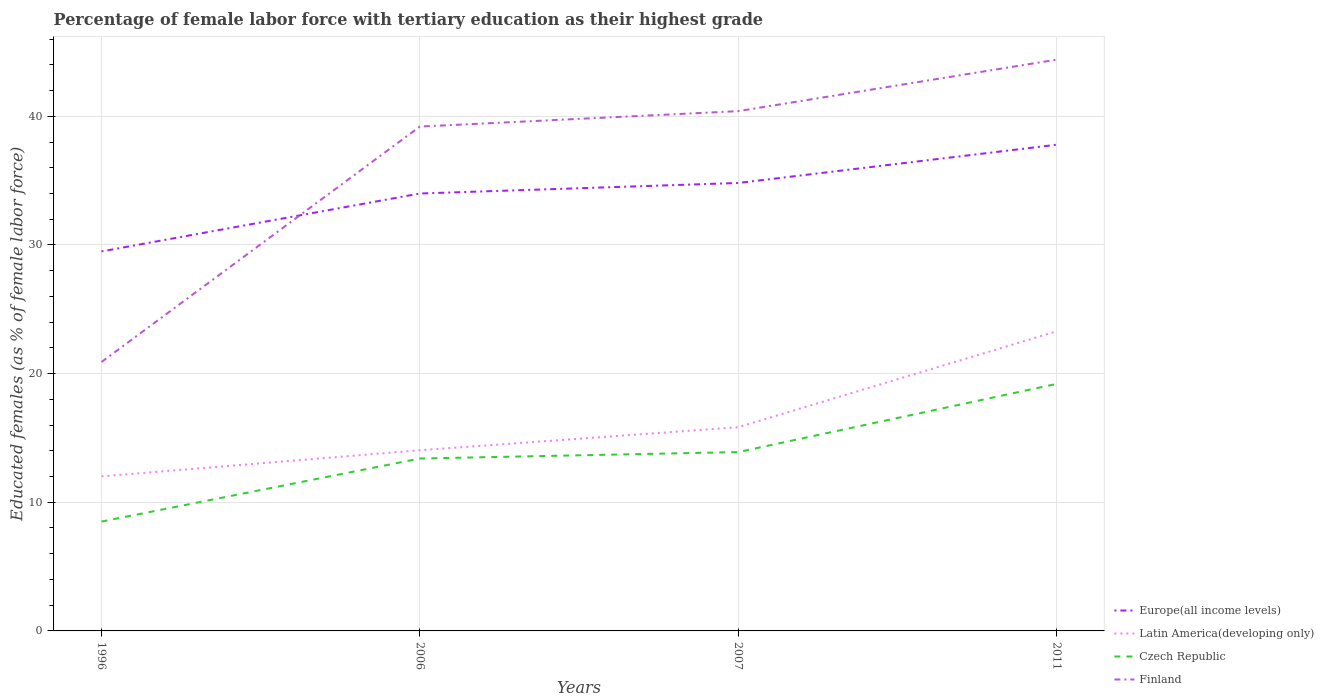How many different coloured lines are there?
Offer a terse response. 4. Is the number of lines equal to the number of legend labels?
Keep it short and to the point. Yes. Across all years, what is the maximum percentage of female labor force with tertiary education in Latin America(developing only)?
Your answer should be very brief. 12.01. In which year was the percentage of female labor force with tertiary education in Czech Republic maximum?
Make the answer very short. 1996. What is the total percentage of female labor force with tertiary education in Europe(all income levels) in the graph?
Your answer should be compact. -0.82. What is the difference between the highest and the second highest percentage of female labor force with tertiary education in Europe(all income levels)?
Make the answer very short. 8.29. What is the difference between the highest and the lowest percentage of female labor force with tertiary education in Finland?
Give a very brief answer. 3. How many lines are there?
Keep it short and to the point. 4. What is the difference between two consecutive major ticks on the Y-axis?
Provide a succinct answer. 10. Where does the legend appear in the graph?
Keep it short and to the point. Bottom right. What is the title of the graph?
Your response must be concise. Percentage of female labor force with tertiary education as their highest grade. Does "Haiti" appear as one of the legend labels in the graph?
Make the answer very short. No. What is the label or title of the X-axis?
Your answer should be very brief. Years. What is the label or title of the Y-axis?
Provide a short and direct response. Educated females (as % of female labor force). What is the Educated females (as % of female labor force) in Europe(all income levels) in 1996?
Your answer should be compact. 29.5. What is the Educated females (as % of female labor force) of Latin America(developing only) in 1996?
Your response must be concise. 12.01. What is the Educated females (as % of female labor force) in Czech Republic in 1996?
Make the answer very short. 8.5. What is the Educated females (as % of female labor force) in Finland in 1996?
Provide a short and direct response. 20.9. What is the Educated females (as % of female labor force) in Europe(all income levels) in 2006?
Your answer should be very brief. 34. What is the Educated females (as % of female labor force) of Latin America(developing only) in 2006?
Offer a terse response. 14.04. What is the Educated females (as % of female labor force) in Czech Republic in 2006?
Offer a very short reply. 13.4. What is the Educated females (as % of female labor force) in Finland in 2006?
Offer a terse response. 39.2. What is the Educated females (as % of female labor force) in Europe(all income levels) in 2007?
Ensure brevity in your answer.  34.82. What is the Educated females (as % of female labor force) in Latin America(developing only) in 2007?
Provide a short and direct response. 15.83. What is the Educated females (as % of female labor force) of Czech Republic in 2007?
Offer a very short reply. 13.9. What is the Educated females (as % of female labor force) in Finland in 2007?
Ensure brevity in your answer.  40.4. What is the Educated females (as % of female labor force) of Europe(all income levels) in 2011?
Your answer should be compact. 37.79. What is the Educated females (as % of female labor force) of Latin America(developing only) in 2011?
Make the answer very short. 23.28. What is the Educated females (as % of female labor force) of Czech Republic in 2011?
Your answer should be compact. 19.2. What is the Educated females (as % of female labor force) in Finland in 2011?
Offer a very short reply. 44.4. Across all years, what is the maximum Educated females (as % of female labor force) in Europe(all income levels)?
Your answer should be compact. 37.79. Across all years, what is the maximum Educated females (as % of female labor force) in Latin America(developing only)?
Offer a terse response. 23.28. Across all years, what is the maximum Educated females (as % of female labor force) of Czech Republic?
Your answer should be compact. 19.2. Across all years, what is the maximum Educated females (as % of female labor force) of Finland?
Offer a very short reply. 44.4. Across all years, what is the minimum Educated females (as % of female labor force) of Europe(all income levels)?
Make the answer very short. 29.5. Across all years, what is the minimum Educated females (as % of female labor force) of Latin America(developing only)?
Make the answer very short. 12.01. Across all years, what is the minimum Educated females (as % of female labor force) in Finland?
Give a very brief answer. 20.9. What is the total Educated females (as % of female labor force) of Europe(all income levels) in the graph?
Offer a terse response. 136.1. What is the total Educated females (as % of female labor force) of Latin America(developing only) in the graph?
Offer a very short reply. 65.17. What is the total Educated females (as % of female labor force) in Finland in the graph?
Your response must be concise. 144.9. What is the difference between the Educated females (as % of female labor force) of Europe(all income levels) in 1996 and that in 2006?
Your answer should be very brief. -4.5. What is the difference between the Educated females (as % of female labor force) of Latin America(developing only) in 1996 and that in 2006?
Provide a succinct answer. -2.03. What is the difference between the Educated females (as % of female labor force) of Finland in 1996 and that in 2006?
Give a very brief answer. -18.3. What is the difference between the Educated females (as % of female labor force) in Europe(all income levels) in 1996 and that in 2007?
Offer a very short reply. -5.32. What is the difference between the Educated females (as % of female labor force) of Latin America(developing only) in 1996 and that in 2007?
Your answer should be very brief. -3.82. What is the difference between the Educated females (as % of female labor force) of Finland in 1996 and that in 2007?
Offer a very short reply. -19.5. What is the difference between the Educated females (as % of female labor force) in Europe(all income levels) in 1996 and that in 2011?
Make the answer very short. -8.29. What is the difference between the Educated females (as % of female labor force) in Latin America(developing only) in 1996 and that in 2011?
Your answer should be compact. -11.27. What is the difference between the Educated females (as % of female labor force) of Czech Republic in 1996 and that in 2011?
Your answer should be compact. -10.7. What is the difference between the Educated females (as % of female labor force) of Finland in 1996 and that in 2011?
Give a very brief answer. -23.5. What is the difference between the Educated females (as % of female labor force) in Europe(all income levels) in 2006 and that in 2007?
Keep it short and to the point. -0.82. What is the difference between the Educated females (as % of female labor force) of Latin America(developing only) in 2006 and that in 2007?
Provide a succinct answer. -1.79. What is the difference between the Educated females (as % of female labor force) in Europe(all income levels) in 2006 and that in 2011?
Provide a succinct answer. -3.79. What is the difference between the Educated females (as % of female labor force) of Latin America(developing only) in 2006 and that in 2011?
Make the answer very short. -9.24. What is the difference between the Educated females (as % of female labor force) of Czech Republic in 2006 and that in 2011?
Offer a terse response. -5.8. What is the difference between the Educated females (as % of female labor force) in Europe(all income levels) in 2007 and that in 2011?
Provide a succinct answer. -2.97. What is the difference between the Educated females (as % of female labor force) in Latin America(developing only) in 2007 and that in 2011?
Make the answer very short. -7.45. What is the difference between the Educated females (as % of female labor force) of Finland in 2007 and that in 2011?
Give a very brief answer. -4. What is the difference between the Educated females (as % of female labor force) of Europe(all income levels) in 1996 and the Educated females (as % of female labor force) of Latin America(developing only) in 2006?
Offer a very short reply. 15.45. What is the difference between the Educated females (as % of female labor force) of Europe(all income levels) in 1996 and the Educated females (as % of female labor force) of Czech Republic in 2006?
Ensure brevity in your answer.  16.1. What is the difference between the Educated females (as % of female labor force) in Europe(all income levels) in 1996 and the Educated females (as % of female labor force) in Finland in 2006?
Offer a very short reply. -9.7. What is the difference between the Educated females (as % of female labor force) of Latin America(developing only) in 1996 and the Educated females (as % of female labor force) of Czech Republic in 2006?
Your answer should be very brief. -1.39. What is the difference between the Educated females (as % of female labor force) in Latin America(developing only) in 1996 and the Educated females (as % of female labor force) in Finland in 2006?
Offer a very short reply. -27.19. What is the difference between the Educated females (as % of female labor force) in Czech Republic in 1996 and the Educated females (as % of female labor force) in Finland in 2006?
Ensure brevity in your answer.  -30.7. What is the difference between the Educated females (as % of female labor force) of Europe(all income levels) in 1996 and the Educated females (as % of female labor force) of Latin America(developing only) in 2007?
Your response must be concise. 13.66. What is the difference between the Educated females (as % of female labor force) of Europe(all income levels) in 1996 and the Educated females (as % of female labor force) of Czech Republic in 2007?
Ensure brevity in your answer.  15.6. What is the difference between the Educated females (as % of female labor force) of Europe(all income levels) in 1996 and the Educated females (as % of female labor force) of Finland in 2007?
Provide a succinct answer. -10.9. What is the difference between the Educated females (as % of female labor force) in Latin America(developing only) in 1996 and the Educated females (as % of female labor force) in Czech Republic in 2007?
Your response must be concise. -1.89. What is the difference between the Educated females (as % of female labor force) of Latin America(developing only) in 1996 and the Educated females (as % of female labor force) of Finland in 2007?
Offer a very short reply. -28.39. What is the difference between the Educated females (as % of female labor force) of Czech Republic in 1996 and the Educated females (as % of female labor force) of Finland in 2007?
Your answer should be very brief. -31.9. What is the difference between the Educated females (as % of female labor force) of Europe(all income levels) in 1996 and the Educated females (as % of female labor force) of Latin America(developing only) in 2011?
Provide a short and direct response. 6.21. What is the difference between the Educated females (as % of female labor force) of Europe(all income levels) in 1996 and the Educated females (as % of female labor force) of Czech Republic in 2011?
Your answer should be very brief. 10.3. What is the difference between the Educated females (as % of female labor force) of Europe(all income levels) in 1996 and the Educated females (as % of female labor force) of Finland in 2011?
Your answer should be compact. -14.9. What is the difference between the Educated females (as % of female labor force) in Latin America(developing only) in 1996 and the Educated females (as % of female labor force) in Czech Republic in 2011?
Make the answer very short. -7.19. What is the difference between the Educated females (as % of female labor force) of Latin America(developing only) in 1996 and the Educated females (as % of female labor force) of Finland in 2011?
Your answer should be compact. -32.39. What is the difference between the Educated females (as % of female labor force) of Czech Republic in 1996 and the Educated females (as % of female labor force) of Finland in 2011?
Offer a very short reply. -35.9. What is the difference between the Educated females (as % of female labor force) in Europe(all income levels) in 2006 and the Educated females (as % of female labor force) in Latin America(developing only) in 2007?
Keep it short and to the point. 18.16. What is the difference between the Educated females (as % of female labor force) of Europe(all income levels) in 2006 and the Educated females (as % of female labor force) of Czech Republic in 2007?
Provide a short and direct response. 20.1. What is the difference between the Educated females (as % of female labor force) in Europe(all income levels) in 2006 and the Educated females (as % of female labor force) in Finland in 2007?
Provide a succinct answer. -6.4. What is the difference between the Educated females (as % of female labor force) of Latin America(developing only) in 2006 and the Educated females (as % of female labor force) of Czech Republic in 2007?
Give a very brief answer. 0.14. What is the difference between the Educated females (as % of female labor force) in Latin America(developing only) in 2006 and the Educated females (as % of female labor force) in Finland in 2007?
Keep it short and to the point. -26.36. What is the difference between the Educated females (as % of female labor force) in Europe(all income levels) in 2006 and the Educated females (as % of female labor force) in Latin America(developing only) in 2011?
Ensure brevity in your answer.  10.71. What is the difference between the Educated females (as % of female labor force) of Europe(all income levels) in 2006 and the Educated females (as % of female labor force) of Czech Republic in 2011?
Offer a terse response. 14.8. What is the difference between the Educated females (as % of female labor force) in Europe(all income levels) in 2006 and the Educated females (as % of female labor force) in Finland in 2011?
Make the answer very short. -10.4. What is the difference between the Educated females (as % of female labor force) of Latin America(developing only) in 2006 and the Educated females (as % of female labor force) of Czech Republic in 2011?
Ensure brevity in your answer.  -5.16. What is the difference between the Educated females (as % of female labor force) of Latin America(developing only) in 2006 and the Educated females (as % of female labor force) of Finland in 2011?
Your answer should be very brief. -30.36. What is the difference between the Educated females (as % of female labor force) in Czech Republic in 2006 and the Educated females (as % of female labor force) in Finland in 2011?
Your answer should be compact. -31. What is the difference between the Educated females (as % of female labor force) of Europe(all income levels) in 2007 and the Educated females (as % of female labor force) of Latin America(developing only) in 2011?
Your answer should be compact. 11.53. What is the difference between the Educated females (as % of female labor force) in Europe(all income levels) in 2007 and the Educated females (as % of female labor force) in Czech Republic in 2011?
Your answer should be very brief. 15.62. What is the difference between the Educated females (as % of female labor force) in Europe(all income levels) in 2007 and the Educated females (as % of female labor force) in Finland in 2011?
Keep it short and to the point. -9.58. What is the difference between the Educated females (as % of female labor force) of Latin America(developing only) in 2007 and the Educated females (as % of female labor force) of Czech Republic in 2011?
Your response must be concise. -3.37. What is the difference between the Educated females (as % of female labor force) of Latin America(developing only) in 2007 and the Educated females (as % of female labor force) of Finland in 2011?
Keep it short and to the point. -28.57. What is the difference between the Educated females (as % of female labor force) in Czech Republic in 2007 and the Educated females (as % of female labor force) in Finland in 2011?
Your response must be concise. -30.5. What is the average Educated females (as % of female labor force) of Europe(all income levels) per year?
Ensure brevity in your answer.  34.02. What is the average Educated females (as % of female labor force) of Latin America(developing only) per year?
Your answer should be compact. 16.29. What is the average Educated females (as % of female labor force) of Czech Republic per year?
Ensure brevity in your answer.  13.75. What is the average Educated females (as % of female labor force) of Finland per year?
Your response must be concise. 36.23. In the year 1996, what is the difference between the Educated females (as % of female labor force) in Europe(all income levels) and Educated females (as % of female labor force) in Latin America(developing only)?
Make the answer very short. 17.48. In the year 1996, what is the difference between the Educated females (as % of female labor force) in Europe(all income levels) and Educated females (as % of female labor force) in Czech Republic?
Your answer should be compact. 21. In the year 1996, what is the difference between the Educated females (as % of female labor force) of Europe(all income levels) and Educated females (as % of female labor force) of Finland?
Offer a very short reply. 8.6. In the year 1996, what is the difference between the Educated females (as % of female labor force) of Latin America(developing only) and Educated females (as % of female labor force) of Czech Republic?
Your answer should be compact. 3.51. In the year 1996, what is the difference between the Educated females (as % of female labor force) in Latin America(developing only) and Educated females (as % of female labor force) in Finland?
Your answer should be compact. -8.89. In the year 2006, what is the difference between the Educated females (as % of female labor force) of Europe(all income levels) and Educated females (as % of female labor force) of Latin America(developing only)?
Ensure brevity in your answer.  19.96. In the year 2006, what is the difference between the Educated females (as % of female labor force) in Europe(all income levels) and Educated females (as % of female labor force) in Czech Republic?
Make the answer very short. 20.6. In the year 2006, what is the difference between the Educated females (as % of female labor force) of Europe(all income levels) and Educated females (as % of female labor force) of Finland?
Make the answer very short. -5.2. In the year 2006, what is the difference between the Educated females (as % of female labor force) of Latin America(developing only) and Educated females (as % of female labor force) of Czech Republic?
Provide a succinct answer. 0.64. In the year 2006, what is the difference between the Educated females (as % of female labor force) in Latin America(developing only) and Educated females (as % of female labor force) in Finland?
Offer a very short reply. -25.16. In the year 2006, what is the difference between the Educated females (as % of female labor force) in Czech Republic and Educated females (as % of female labor force) in Finland?
Make the answer very short. -25.8. In the year 2007, what is the difference between the Educated females (as % of female labor force) in Europe(all income levels) and Educated females (as % of female labor force) in Latin America(developing only)?
Your answer should be compact. 18.98. In the year 2007, what is the difference between the Educated females (as % of female labor force) of Europe(all income levels) and Educated females (as % of female labor force) of Czech Republic?
Your answer should be compact. 20.92. In the year 2007, what is the difference between the Educated females (as % of female labor force) in Europe(all income levels) and Educated females (as % of female labor force) in Finland?
Offer a very short reply. -5.58. In the year 2007, what is the difference between the Educated females (as % of female labor force) in Latin America(developing only) and Educated females (as % of female labor force) in Czech Republic?
Give a very brief answer. 1.93. In the year 2007, what is the difference between the Educated females (as % of female labor force) in Latin America(developing only) and Educated females (as % of female labor force) in Finland?
Offer a terse response. -24.57. In the year 2007, what is the difference between the Educated females (as % of female labor force) of Czech Republic and Educated females (as % of female labor force) of Finland?
Your answer should be compact. -26.5. In the year 2011, what is the difference between the Educated females (as % of female labor force) in Europe(all income levels) and Educated females (as % of female labor force) in Latin America(developing only)?
Give a very brief answer. 14.5. In the year 2011, what is the difference between the Educated females (as % of female labor force) of Europe(all income levels) and Educated females (as % of female labor force) of Czech Republic?
Your response must be concise. 18.59. In the year 2011, what is the difference between the Educated females (as % of female labor force) of Europe(all income levels) and Educated females (as % of female labor force) of Finland?
Your response must be concise. -6.61. In the year 2011, what is the difference between the Educated females (as % of female labor force) in Latin America(developing only) and Educated females (as % of female labor force) in Czech Republic?
Ensure brevity in your answer.  4.08. In the year 2011, what is the difference between the Educated females (as % of female labor force) in Latin America(developing only) and Educated females (as % of female labor force) in Finland?
Keep it short and to the point. -21.11. In the year 2011, what is the difference between the Educated females (as % of female labor force) of Czech Republic and Educated females (as % of female labor force) of Finland?
Offer a very short reply. -25.2. What is the ratio of the Educated females (as % of female labor force) of Europe(all income levels) in 1996 to that in 2006?
Your answer should be compact. 0.87. What is the ratio of the Educated females (as % of female labor force) in Latin America(developing only) in 1996 to that in 2006?
Keep it short and to the point. 0.86. What is the ratio of the Educated females (as % of female labor force) of Czech Republic in 1996 to that in 2006?
Give a very brief answer. 0.63. What is the ratio of the Educated females (as % of female labor force) of Finland in 1996 to that in 2006?
Your answer should be very brief. 0.53. What is the ratio of the Educated females (as % of female labor force) of Europe(all income levels) in 1996 to that in 2007?
Keep it short and to the point. 0.85. What is the ratio of the Educated females (as % of female labor force) of Latin America(developing only) in 1996 to that in 2007?
Your answer should be compact. 0.76. What is the ratio of the Educated females (as % of female labor force) of Czech Republic in 1996 to that in 2007?
Offer a very short reply. 0.61. What is the ratio of the Educated females (as % of female labor force) in Finland in 1996 to that in 2007?
Your response must be concise. 0.52. What is the ratio of the Educated females (as % of female labor force) of Europe(all income levels) in 1996 to that in 2011?
Your answer should be compact. 0.78. What is the ratio of the Educated females (as % of female labor force) of Latin America(developing only) in 1996 to that in 2011?
Keep it short and to the point. 0.52. What is the ratio of the Educated females (as % of female labor force) of Czech Republic in 1996 to that in 2011?
Make the answer very short. 0.44. What is the ratio of the Educated females (as % of female labor force) in Finland in 1996 to that in 2011?
Give a very brief answer. 0.47. What is the ratio of the Educated females (as % of female labor force) in Europe(all income levels) in 2006 to that in 2007?
Your response must be concise. 0.98. What is the ratio of the Educated females (as % of female labor force) in Latin America(developing only) in 2006 to that in 2007?
Offer a terse response. 0.89. What is the ratio of the Educated females (as % of female labor force) of Czech Republic in 2006 to that in 2007?
Make the answer very short. 0.96. What is the ratio of the Educated females (as % of female labor force) in Finland in 2006 to that in 2007?
Ensure brevity in your answer.  0.97. What is the ratio of the Educated females (as % of female labor force) of Europe(all income levels) in 2006 to that in 2011?
Your response must be concise. 0.9. What is the ratio of the Educated females (as % of female labor force) of Latin America(developing only) in 2006 to that in 2011?
Offer a terse response. 0.6. What is the ratio of the Educated females (as % of female labor force) in Czech Republic in 2006 to that in 2011?
Your answer should be very brief. 0.7. What is the ratio of the Educated females (as % of female labor force) in Finland in 2006 to that in 2011?
Your answer should be very brief. 0.88. What is the ratio of the Educated females (as % of female labor force) in Europe(all income levels) in 2007 to that in 2011?
Your answer should be compact. 0.92. What is the ratio of the Educated females (as % of female labor force) in Latin America(developing only) in 2007 to that in 2011?
Keep it short and to the point. 0.68. What is the ratio of the Educated females (as % of female labor force) of Czech Republic in 2007 to that in 2011?
Offer a very short reply. 0.72. What is the ratio of the Educated females (as % of female labor force) of Finland in 2007 to that in 2011?
Keep it short and to the point. 0.91. What is the difference between the highest and the second highest Educated females (as % of female labor force) in Europe(all income levels)?
Offer a very short reply. 2.97. What is the difference between the highest and the second highest Educated females (as % of female labor force) of Latin America(developing only)?
Provide a succinct answer. 7.45. What is the difference between the highest and the second highest Educated females (as % of female labor force) in Czech Republic?
Provide a succinct answer. 5.3. What is the difference between the highest and the lowest Educated females (as % of female labor force) in Europe(all income levels)?
Provide a succinct answer. 8.29. What is the difference between the highest and the lowest Educated females (as % of female labor force) in Latin America(developing only)?
Give a very brief answer. 11.27. What is the difference between the highest and the lowest Educated females (as % of female labor force) in Czech Republic?
Give a very brief answer. 10.7. 